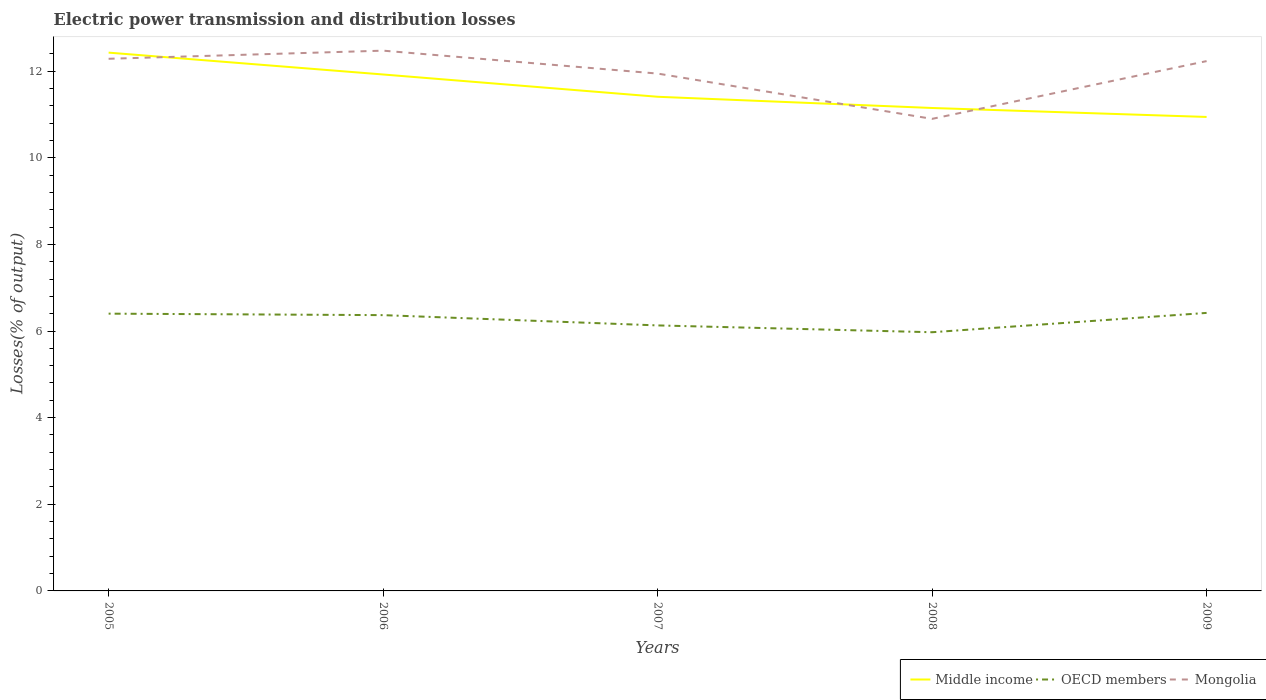How many different coloured lines are there?
Offer a very short reply. 3. Across all years, what is the maximum electric power transmission and distribution losses in Mongolia?
Give a very brief answer. 10.9. What is the total electric power transmission and distribution losses in OECD members in the graph?
Give a very brief answer. 0.39. What is the difference between the highest and the second highest electric power transmission and distribution losses in OECD members?
Give a very brief answer. 0.45. Is the electric power transmission and distribution losses in Middle income strictly greater than the electric power transmission and distribution losses in Mongolia over the years?
Offer a very short reply. No. Does the graph contain any zero values?
Offer a terse response. No. Does the graph contain grids?
Offer a very short reply. No. Where does the legend appear in the graph?
Offer a terse response. Bottom right. What is the title of the graph?
Provide a short and direct response. Electric power transmission and distribution losses. What is the label or title of the X-axis?
Make the answer very short. Years. What is the label or title of the Y-axis?
Your answer should be compact. Losses(% of output). What is the Losses(% of output) of Middle income in 2005?
Your answer should be very brief. 12.43. What is the Losses(% of output) of OECD members in 2005?
Ensure brevity in your answer.  6.4. What is the Losses(% of output) of Mongolia in 2005?
Offer a very short reply. 12.28. What is the Losses(% of output) of Middle income in 2006?
Offer a terse response. 11.92. What is the Losses(% of output) of OECD members in 2006?
Provide a succinct answer. 6.37. What is the Losses(% of output) of Mongolia in 2006?
Make the answer very short. 12.47. What is the Losses(% of output) of Middle income in 2007?
Offer a terse response. 11.41. What is the Losses(% of output) of OECD members in 2007?
Your answer should be compact. 6.13. What is the Losses(% of output) in Mongolia in 2007?
Ensure brevity in your answer.  11.94. What is the Losses(% of output) in Middle income in 2008?
Make the answer very short. 11.15. What is the Losses(% of output) in OECD members in 2008?
Keep it short and to the point. 5.97. What is the Losses(% of output) of Mongolia in 2008?
Provide a short and direct response. 10.9. What is the Losses(% of output) of Middle income in 2009?
Make the answer very short. 10.94. What is the Losses(% of output) of OECD members in 2009?
Your answer should be very brief. 6.42. What is the Losses(% of output) in Mongolia in 2009?
Give a very brief answer. 12.23. Across all years, what is the maximum Losses(% of output) of Middle income?
Provide a short and direct response. 12.43. Across all years, what is the maximum Losses(% of output) of OECD members?
Give a very brief answer. 6.42. Across all years, what is the maximum Losses(% of output) in Mongolia?
Provide a short and direct response. 12.47. Across all years, what is the minimum Losses(% of output) of Middle income?
Keep it short and to the point. 10.94. Across all years, what is the minimum Losses(% of output) of OECD members?
Make the answer very short. 5.97. Across all years, what is the minimum Losses(% of output) in Mongolia?
Your answer should be compact. 10.9. What is the total Losses(% of output) of Middle income in the graph?
Keep it short and to the point. 57.84. What is the total Losses(% of output) in OECD members in the graph?
Keep it short and to the point. 31.29. What is the total Losses(% of output) of Mongolia in the graph?
Ensure brevity in your answer.  59.83. What is the difference between the Losses(% of output) of Middle income in 2005 and that in 2006?
Provide a succinct answer. 0.5. What is the difference between the Losses(% of output) in OECD members in 2005 and that in 2006?
Your answer should be very brief. 0.03. What is the difference between the Losses(% of output) of Mongolia in 2005 and that in 2006?
Offer a terse response. -0.19. What is the difference between the Losses(% of output) of Middle income in 2005 and that in 2007?
Your answer should be very brief. 1.02. What is the difference between the Losses(% of output) of OECD members in 2005 and that in 2007?
Your answer should be very brief. 0.27. What is the difference between the Losses(% of output) in Mongolia in 2005 and that in 2007?
Your response must be concise. 0.34. What is the difference between the Losses(% of output) in Middle income in 2005 and that in 2008?
Give a very brief answer. 1.28. What is the difference between the Losses(% of output) in OECD members in 2005 and that in 2008?
Keep it short and to the point. 0.43. What is the difference between the Losses(% of output) of Mongolia in 2005 and that in 2008?
Your answer should be compact. 1.39. What is the difference between the Losses(% of output) of Middle income in 2005 and that in 2009?
Provide a short and direct response. 1.49. What is the difference between the Losses(% of output) in OECD members in 2005 and that in 2009?
Ensure brevity in your answer.  -0.02. What is the difference between the Losses(% of output) of Mongolia in 2005 and that in 2009?
Keep it short and to the point. 0.05. What is the difference between the Losses(% of output) of Middle income in 2006 and that in 2007?
Provide a short and direct response. 0.51. What is the difference between the Losses(% of output) in OECD members in 2006 and that in 2007?
Keep it short and to the point. 0.24. What is the difference between the Losses(% of output) of Mongolia in 2006 and that in 2007?
Provide a short and direct response. 0.53. What is the difference between the Losses(% of output) in Middle income in 2006 and that in 2008?
Give a very brief answer. 0.77. What is the difference between the Losses(% of output) in OECD members in 2006 and that in 2008?
Provide a short and direct response. 0.39. What is the difference between the Losses(% of output) of Mongolia in 2006 and that in 2008?
Ensure brevity in your answer.  1.57. What is the difference between the Losses(% of output) of Middle income in 2006 and that in 2009?
Make the answer very short. 0.98. What is the difference between the Losses(% of output) in OECD members in 2006 and that in 2009?
Keep it short and to the point. -0.05. What is the difference between the Losses(% of output) in Mongolia in 2006 and that in 2009?
Offer a terse response. 0.24. What is the difference between the Losses(% of output) in Middle income in 2007 and that in 2008?
Your answer should be compact. 0.26. What is the difference between the Losses(% of output) in OECD members in 2007 and that in 2008?
Provide a short and direct response. 0.16. What is the difference between the Losses(% of output) of Mongolia in 2007 and that in 2008?
Give a very brief answer. 1.05. What is the difference between the Losses(% of output) in Middle income in 2007 and that in 2009?
Offer a very short reply. 0.47. What is the difference between the Losses(% of output) of OECD members in 2007 and that in 2009?
Make the answer very short. -0.29. What is the difference between the Losses(% of output) of Mongolia in 2007 and that in 2009?
Provide a succinct answer. -0.29. What is the difference between the Losses(% of output) of Middle income in 2008 and that in 2009?
Keep it short and to the point. 0.21. What is the difference between the Losses(% of output) of OECD members in 2008 and that in 2009?
Give a very brief answer. -0.45. What is the difference between the Losses(% of output) in Mongolia in 2008 and that in 2009?
Provide a succinct answer. -1.33. What is the difference between the Losses(% of output) in Middle income in 2005 and the Losses(% of output) in OECD members in 2006?
Provide a succinct answer. 6.06. What is the difference between the Losses(% of output) of Middle income in 2005 and the Losses(% of output) of Mongolia in 2006?
Make the answer very short. -0.05. What is the difference between the Losses(% of output) in OECD members in 2005 and the Losses(% of output) in Mongolia in 2006?
Offer a terse response. -6.07. What is the difference between the Losses(% of output) in Middle income in 2005 and the Losses(% of output) in OECD members in 2007?
Your answer should be compact. 6.3. What is the difference between the Losses(% of output) of Middle income in 2005 and the Losses(% of output) of Mongolia in 2007?
Make the answer very short. 0.48. What is the difference between the Losses(% of output) in OECD members in 2005 and the Losses(% of output) in Mongolia in 2007?
Your answer should be compact. -5.54. What is the difference between the Losses(% of output) in Middle income in 2005 and the Losses(% of output) in OECD members in 2008?
Ensure brevity in your answer.  6.45. What is the difference between the Losses(% of output) of Middle income in 2005 and the Losses(% of output) of Mongolia in 2008?
Ensure brevity in your answer.  1.53. What is the difference between the Losses(% of output) in OECD members in 2005 and the Losses(% of output) in Mongolia in 2008?
Keep it short and to the point. -4.5. What is the difference between the Losses(% of output) in Middle income in 2005 and the Losses(% of output) in OECD members in 2009?
Your answer should be very brief. 6.01. What is the difference between the Losses(% of output) in Middle income in 2005 and the Losses(% of output) in Mongolia in 2009?
Provide a succinct answer. 0.2. What is the difference between the Losses(% of output) of OECD members in 2005 and the Losses(% of output) of Mongolia in 2009?
Ensure brevity in your answer.  -5.83. What is the difference between the Losses(% of output) of Middle income in 2006 and the Losses(% of output) of OECD members in 2007?
Ensure brevity in your answer.  5.79. What is the difference between the Losses(% of output) of Middle income in 2006 and the Losses(% of output) of Mongolia in 2007?
Keep it short and to the point. -0.02. What is the difference between the Losses(% of output) of OECD members in 2006 and the Losses(% of output) of Mongolia in 2007?
Your answer should be compact. -5.58. What is the difference between the Losses(% of output) in Middle income in 2006 and the Losses(% of output) in OECD members in 2008?
Provide a succinct answer. 5.95. What is the difference between the Losses(% of output) in Middle income in 2006 and the Losses(% of output) in Mongolia in 2008?
Your answer should be compact. 1.02. What is the difference between the Losses(% of output) of OECD members in 2006 and the Losses(% of output) of Mongolia in 2008?
Offer a terse response. -4.53. What is the difference between the Losses(% of output) in Middle income in 2006 and the Losses(% of output) in OECD members in 2009?
Your answer should be compact. 5.5. What is the difference between the Losses(% of output) in Middle income in 2006 and the Losses(% of output) in Mongolia in 2009?
Your answer should be very brief. -0.31. What is the difference between the Losses(% of output) in OECD members in 2006 and the Losses(% of output) in Mongolia in 2009?
Make the answer very short. -5.86. What is the difference between the Losses(% of output) in Middle income in 2007 and the Losses(% of output) in OECD members in 2008?
Offer a very short reply. 5.44. What is the difference between the Losses(% of output) of Middle income in 2007 and the Losses(% of output) of Mongolia in 2008?
Offer a terse response. 0.51. What is the difference between the Losses(% of output) in OECD members in 2007 and the Losses(% of output) in Mongolia in 2008?
Your answer should be compact. -4.77. What is the difference between the Losses(% of output) in Middle income in 2007 and the Losses(% of output) in OECD members in 2009?
Offer a very short reply. 4.99. What is the difference between the Losses(% of output) of Middle income in 2007 and the Losses(% of output) of Mongolia in 2009?
Ensure brevity in your answer.  -0.82. What is the difference between the Losses(% of output) in OECD members in 2007 and the Losses(% of output) in Mongolia in 2009?
Offer a very short reply. -6.1. What is the difference between the Losses(% of output) in Middle income in 2008 and the Losses(% of output) in OECD members in 2009?
Make the answer very short. 4.73. What is the difference between the Losses(% of output) in Middle income in 2008 and the Losses(% of output) in Mongolia in 2009?
Ensure brevity in your answer.  -1.08. What is the difference between the Losses(% of output) of OECD members in 2008 and the Losses(% of output) of Mongolia in 2009?
Offer a very short reply. -6.26. What is the average Losses(% of output) in Middle income per year?
Offer a terse response. 11.57. What is the average Losses(% of output) in OECD members per year?
Ensure brevity in your answer.  6.26. What is the average Losses(% of output) in Mongolia per year?
Your response must be concise. 11.97. In the year 2005, what is the difference between the Losses(% of output) of Middle income and Losses(% of output) of OECD members?
Provide a succinct answer. 6.03. In the year 2005, what is the difference between the Losses(% of output) in Middle income and Losses(% of output) in Mongolia?
Offer a very short reply. 0.14. In the year 2005, what is the difference between the Losses(% of output) in OECD members and Losses(% of output) in Mongolia?
Offer a very short reply. -5.88. In the year 2006, what is the difference between the Losses(% of output) of Middle income and Losses(% of output) of OECD members?
Ensure brevity in your answer.  5.56. In the year 2006, what is the difference between the Losses(% of output) of Middle income and Losses(% of output) of Mongolia?
Your response must be concise. -0.55. In the year 2006, what is the difference between the Losses(% of output) in OECD members and Losses(% of output) in Mongolia?
Keep it short and to the point. -6.11. In the year 2007, what is the difference between the Losses(% of output) of Middle income and Losses(% of output) of OECD members?
Your answer should be compact. 5.28. In the year 2007, what is the difference between the Losses(% of output) in Middle income and Losses(% of output) in Mongolia?
Keep it short and to the point. -0.54. In the year 2007, what is the difference between the Losses(% of output) of OECD members and Losses(% of output) of Mongolia?
Ensure brevity in your answer.  -5.81. In the year 2008, what is the difference between the Losses(% of output) in Middle income and Losses(% of output) in OECD members?
Make the answer very short. 5.18. In the year 2008, what is the difference between the Losses(% of output) of Middle income and Losses(% of output) of Mongolia?
Provide a succinct answer. 0.25. In the year 2008, what is the difference between the Losses(% of output) in OECD members and Losses(% of output) in Mongolia?
Ensure brevity in your answer.  -4.93. In the year 2009, what is the difference between the Losses(% of output) of Middle income and Losses(% of output) of OECD members?
Your answer should be very brief. 4.52. In the year 2009, what is the difference between the Losses(% of output) of Middle income and Losses(% of output) of Mongolia?
Your answer should be very brief. -1.29. In the year 2009, what is the difference between the Losses(% of output) in OECD members and Losses(% of output) in Mongolia?
Your answer should be compact. -5.81. What is the ratio of the Losses(% of output) of Middle income in 2005 to that in 2006?
Provide a short and direct response. 1.04. What is the ratio of the Losses(% of output) in OECD members in 2005 to that in 2006?
Your response must be concise. 1.01. What is the ratio of the Losses(% of output) of Mongolia in 2005 to that in 2006?
Make the answer very short. 0.98. What is the ratio of the Losses(% of output) of Middle income in 2005 to that in 2007?
Keep it short and to the point. 1.09. What is the ratio of the Losses(% of output) of OECD members in 2005 to that in 2007?
Your answer should be very brief. 1.04. What is the ratio of the Losses(% of output) of Mongolia in 2005 to that in 2007?
Offer a very short reply. 1.03. What is the ratio of the Losses(% of output) of Middle income in 2005 to that in 2008?
Provide a succinct answer. 1.11. What is the ratio of the Losses(% of output) in OECD members in 2005 to that in 2008?
Offer a terse response. 1.07. What is the ratio of the Losses(% of output) in Mongolia in 2005 to that in 2008?
Provide a succinct answer. 1.13. What is the ratio of the Losses(% of output) of Middle income in 2005 to that in 2009?
Provide a short and direct response. 1.14. What is the ratio of the Losses(% of output) in OECD members in 2005 to that in 2009?
Ensure brevity in your answer.  1. What is the ratio of the Losses(% of output) of Middle income in 2006 to that in 2007?
Provide a short and direct response. 1.05. What is the ratio of the Losses(% of output) of OECD members in 2006 to that in 2007?
Ensure brevity in your answer.  1.04. What is the ratio of the Losses(% of output) in Mongolia in 2006 to that in 2007?
Your answer should be very brief. 1.04. What is the ratio of the Losses(% of output) of Middle income in 2006 to that in 2008?
Your answer should be very brief. 1.07. What is the ratio of the Losses(% of output) in OECD members in 2006 to that in 2008?
Offer a very short reply. 1.07. What is the ratio of the Losses(% of output) of Mongolia in 2006 to that in 2008?
Keep it short and to the point. 1.14. What is the ratio of the Losses(% of output) in Middle income in 2006 to that in 2009?
Keep it short and to the point. 1.09. What is the ratio of the Losses(% of output) in OECD members in 2006 to that in 2009?
Your answer should be compact. 0.99. What is the ratio of the Losses(% of output) in Mongolia in 2006 to that in 2009?
Provide a succinct answer. 1.02. What is the ratio of the Losses(% of output) of Middle income in 2007 to that in 2008?
Provide a succinct answer. 1.02. What is the ratio of the Losses(% of output) of OECD members in 2007 to that in 2008?
Offer a very short reply. 1.03. What is the ratio of the Losses(% of output) of Mongolia in 2007 to that in 2008?
Offer a terse response. 1.1. What is the ratio of the Losses(% of output) of Middle income in 2007 to that in 2009?
Provide a succinct answer. 1.04. What is the ratio of the Losses(% of output) of OECD members in 2007 to that in 2009?
Keep it short and to the point. 0.95. What is the ratio of the Losses(% of output) of Mongolia in 2007 to that in 2009?
Your answer should be very brief. 0.98. What is the ratio of the Losses(% of output) in Middle income in 2008 to that in 2009?
Provide a succinct answer. 1.02. What is the ratio of the Losses(% of output) of OECD members in 2008 to that in 2009?
Your answer should be very brief. 0.93. What is the ratio of the Losses(% of output) of Mongolia in 2008 to that in 2009?
Offer a very short reply. 0.89. What is the difference between the highest and the second highest Losses(% of output) in Middle income?
Offer a terse response. 0.5. What is the difference between the highest and the second highest Losses(% of output) in OECD members?
Give a very brief answer. 0.02. What is the difference between the highest and the second highest Losses(% of output) in Mongolia?
Provide a short and direct response. 0.19. What is the difference between the highest and the lowest Losses(% of output) of Middle income?
Your answer should be very brief. 1.49. What is the difference between the highest and the lowest Losses(% of output) of OECD members?
Your answer should be very brief. 0.45. What is the difference between the highest and the lowest Losses(% of output) in Mongolia?
Keep it short and to the point. 1.57. 